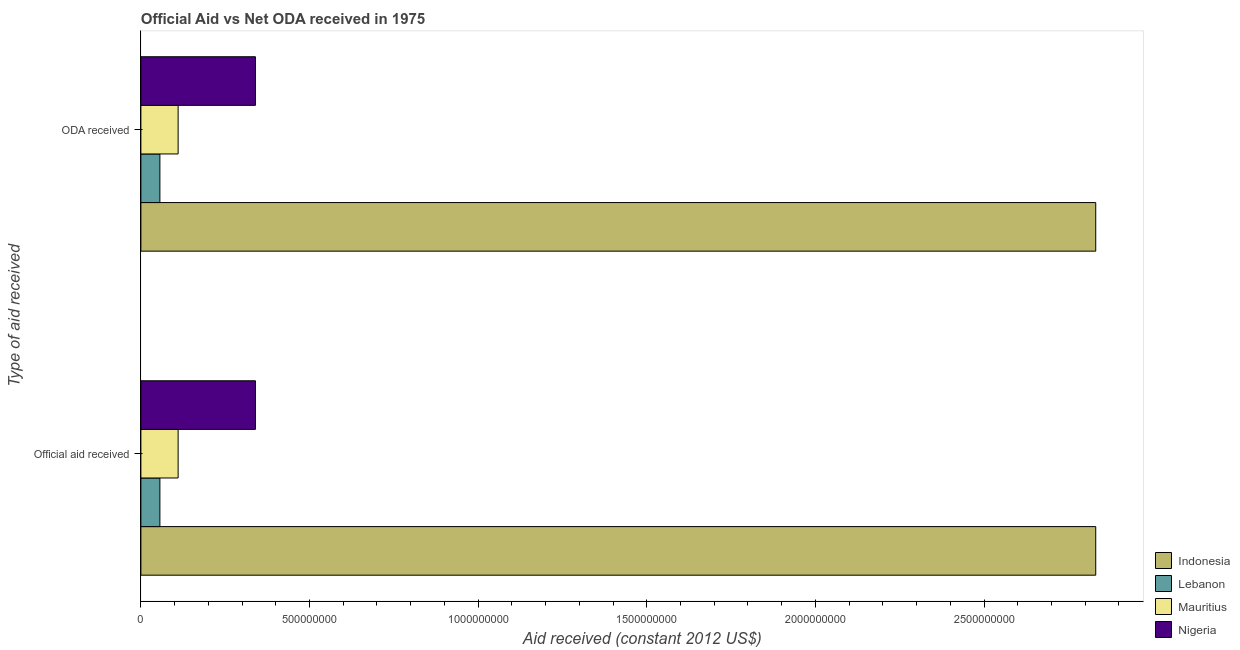How many different coloured bars are there?
Keep it short and to the point. 4. Are the number of bars per tick equal to the number of legend labels?
Make the answer very short. Yes. Are the number of bars on each tick of the Y-axis equal?
Keep it short and to the point. Yes. How many bars are there on the 1st tick from the top?
Keep it short and to the point. 4. What is the label of the 1st group of bars from the top?
Keep it short and to the point. ODA received. What is the oda received in Nigeria?
Provide a short and direct response. 3.40e+08. Across all countries, what is the maximum oda received?
Offer a terse response. 2.83e+09. Across all countries, what is the minimum oda received?
Offer a terse response. 5.63e+07. In which country was the official aid received minimum?
Ensure brevity in your answer.  Lebanon. What is the total oda received in the graph?
Keep it short and to the point. 3.34e+09. What is the difference between the oda received in Mauritius and that in Indonesia?
Provide a short and direct response. -2.72e+09. What is the difference between the oda received in Indonesia and the official aid received in Mauritius?
Keep it short and to the point. 2.72e+09. What is the average official aid received per country?
Provide a succinct answer. 8.34e+08. What is the difference between the official aid received and oda received in Lebanon?
Give a very brief answer. 0. What is the ratio of the official aid received in Mauritius to that in Indonesia?
Provide a succinct answer. 0.04. Is the oda received in Mauritius less than that in Indonesia?
Give a very brief answer. Yes. In how many countries, is the oda received greater than the average oda received taken over all countries?
Provide a succinct answer. 1. What does the 4th bar from the top in Official aid received represents?
Ensure brevity in your answer.  Indonesia. How many bars are there?
Your answer should be compact. 8. Are all the bars in the graph horizontal?
Ensure brevity in your answer.  Yes. What is the difference between two consecutive major ticks on the X-axis?
Give a very brief answer. 5.00e+08. Are the values on the major ticks of X-axis written in scientific E-notation?
Provide a succinct answer. No. Does the graph contain any zero values?
Offer a very short reply. No. Where does the legend appear in the graph?
Your response must be concise. Bottom right. How many legend labels are there?
Offer a very short reply. 4. How are the legend labels stacked?
Your response must be concise. Vertical. What is the title of the graph?
Provide a short and direct response. Official Aid vs Net ODA received in 1975 . What is the label or title of the X-axis?
Keep it short and to the point. Aid received (constant 2012 US$). What is the label or title of the Y-axis?
Your answer should be very brief. Type of aid received. What is the Aid received (constant 2012 US$) in Indonesia in Official aid received?
Give a very brief answer. 2.83e+09. What is the Aid received (constant 2012 US$) of Lebanon in Official aid received?
Your answer should be compact. 5.63e+07. What is the Aid received (constant 2012 US$) in Mauritius in Official aid received?
Offer a very short reply. 1.10e+08. What is the Aid received (constant 2012 US$) in Nigeria in Official aid received?
Your response must be concise. 3.40e+08. What is the Aid received (constant 2012 US$) of Indonesia in ODA received?
Provide a short and direct response. 2.83e+09. What is the Aid received (constant 2012 US$) in Lebanon in ODA received?
Offer a terse response. 5.63e+07. What is the Aid received (constant 2012 US$) in Mauritius in ODA received?
Give a very brief answer. 1.10e+08. What is the Aid received (constant 2012 US$) of Nigeria in ODA received?
Your answer should be very brief. 3.40e+08. Across all Type of aid received, what is the maximum Aid received (constant 2012 US$) in Indonesia?
Provide a succinct answer. 2.83e+09. Across all Type of aid received, what is the maximum Aid received (constant 2012 US$) in Lebanon?
Your response must be concise. 5.63e+07. Across all Type of aid received, what is the maximum Aid received (constant 2012 US$) of Mauritius?
Give a very brief answer. 1.10e+08. Across all Type of aid received, what is the maximum Aid received (constant 2012 US$) in Nigeria?
Offer a terse response. 3.40e+08. Across all Type of aid received, what is the minimum Aid received (constant 2012 US$) in Indonesia?
Ensure brevity in your answer.  2.83e+09. Across all Type of aid received, what is the minimum Aid received (constant 2012 US$) of Lebanon?
Your response must be concise. 5.63e+07. Across all Type of aid received, what is the minimum Aid received (constant 2012 US$) in Mauritius?
Provide a short and direct response. 1.10e+08. Across all Type of aid received, what is the minimum Aid received (constant 2012 US$) in Nigeria?
Offer a very short reply. 3.40e+08. What is the total Aid received (constant 2012 US$) of Indonesia in the graph?
Your answer should be compact. 5.66e+09. What is the total Aid received (constant 2012 US$) in Lebanon in the graph?
Offer a terse response. 1.13e+08. What is the total Aid received (constant 2012 US$) of Mauritius in the graph?
Make the answer very short. 2.21e+08. What is the total Aid received (constant 2012 US$) of Nigeria in the graph?
Your answer should be compact. 6.79e+08. What is the difference between the Aid received (constant 2012 US$) in Indonesia in Official aid received and that in ODA received?
Provide a short and direct response. 0. What is the difference between the Aid received (constant 2012 US$) of Lebanon in Official aid received and that in ODA received?
Provide a short and direct response. 0. What is the difference between the Aid received (constant 2012 US$) in Mauritius in Official aid received and that in ODA received?
Keep it short and to the point. 0. What is the difference between the Aid received (constant 2012 US$) of Indonesia in Official aid received and the Aid received (constant 2012 US$) of Lebanon in ODA received?
Offer a terse response. 2.77e+09. What is the difference between the Aid received (constant 2012 US$) of Indonesia in Official aid received and the Aid received (constant 2012 US$) of Mauritius in ODA received?
Your answer should be very brief. 2.72e+09. What is the difference between the Aid received (constant 2012 US$) in Indonesia in Official aid received and the Aid received (constant 2012 US$) in Nigeria in ODA received?
Offer a terse response. 2.49e+09. What is the difference between the Aid received (constant 2012 US$) of Lebanon in Official aid received and the Aid received (constant 2012 US$) of Mauritius in ODA received?
Keep it short and to the point. -5.41e+07. What is the difference between the Aid received (constant 2012 US$) in Lebanon in Official aid received and the Aid received (constant 2012 US$) in Nigeria in ODA received?
Keep it short and to the point. -2.83e+08. What is the difference between the Aid received (constant 2012 US$) of Mauritius in Official aid received and the Aid received (constant 2012 US$) of Nigeria in ODA received?
Give a very brief answer. -2.29e+08. What is the average Aid received (constant 2012 US$) of Indonesia per Type of aid received?
Make the answer very short. 2.83e+09. What is the average Aid received (constant 2012 US$) of Lebanon per Type of aid received?
Provide a succinct answer. 5.63e+07. What is the average Aid received (constant 2012 US$) in Mauritius per Type of aid received?
Give a very brief answer. 1.10e+08. What is the average Aid received (constant 2012 US$) in Nigeria per Type of aid received?
Keep it short and to the point. 3.40e+08. What is the difference between the Aid received (constant 2012 US$) in Indonesia and Aid received (constant 2012 US$) in Lebanon in Official aid received?
Your answer should be very brief. 2.77e+09. What is the difference between the Aid received (constant 2012 US$) in Indonesia and Aid received (constant 2012 US$) in Mauritius in Official aid received?
Offer a very short reply. 2.72e+09. What is the difference between the Aid received (constant 2012 US$) in Indonesia and Aid received (constant 2012 US$) in Nigeria in Official aid received?
Your response must be concise. 2.49e+09. What is the difference between the Aid received (constant 2012 US$) in Lebanon and Aid received (constant 2012 US$) in Mauritius in Official aid received?
Ensure brevity in your answer.  -5.41e+07. What is the difference between the Aid received (constant 2012 US$) of Lebanon and Aid received (constant 2012 US$) of Nigeria in Official aid received?
Provide a succinct answer. -2.83e+08. What is the difference between the Aid received (constant 2012 US$) of Mauritius and Aid received (constant 2012 US$) of Nigeria in Official aid received?
Your answer should be very brief. -2.29e+08. What is the difference between the Aid received (constant 2012 US$) in Indonesia and Aid received (constant 2012 US$) in Lebanon in ODA received?
Your response must be concise. 2.77e+09. What is the difference between the Aid received (constant 2012 US$) in Indonesia and Aid received (constant 2012 US$) in Mauritius in ODA received?
Keep it short and to the point. 2.72e+09. What is the difference between the Aid received (constant 2012 US$) in Indonesia and Aid received (constant 2012 US$) in Nigeria in ODA received?
Ensure brevity in your answer.  2.49e+09. What is the difference between the Aid received (constant 2012 US$) of Lebanon and Aid received (constant 2012 US$) of Mauritius in ODA received?
Your answer should be compact. -5.41e+07. What is the difference between the Aid received (constant 2012 US$) of Lebanon and Aid received (constant 2012 US$) of Nigeria in ODA received?
Your response must be concise. -2.83e+08. What is the difference between the Aid received (constant 2012 US$) of Mauritius and Aid received (constant 2012 US$) of Nigeria in ODA received?
Offer a very short reply. -2.29e+08. What is the ratio of the Aid received (constant 2012 US$) in Indonesia in Official aid received to that in ODA received?
Offer a very short reply. 1. What is the ratio of the Aid received (constant 2012 US$) in Lebanon in Official aid received to that in ODA received?
Your response must be concise. 1. What is the difference between the highest and the second highest Aid received (constant 2012 US$) of Indonesia?
Keep it short and to the point. 0. What is the difference between the highest and the second highest Aid received (constant 2012 US$) in Lebanon?
Provide a succinct answer. 0. What is the difference between the highest and the second highest Aid received (constant 2012 US$) in Nigeria?
Your answer should be compact. 0. What is the difference between the highest and the lowest Aid received (constant 2012 US$) of Lebanon?
Offer a terse response. 0. What is the difference between the highest and the lowest Aid received (constant 2012 US$) of Mauritius?
Your answer should be compact. 0. 